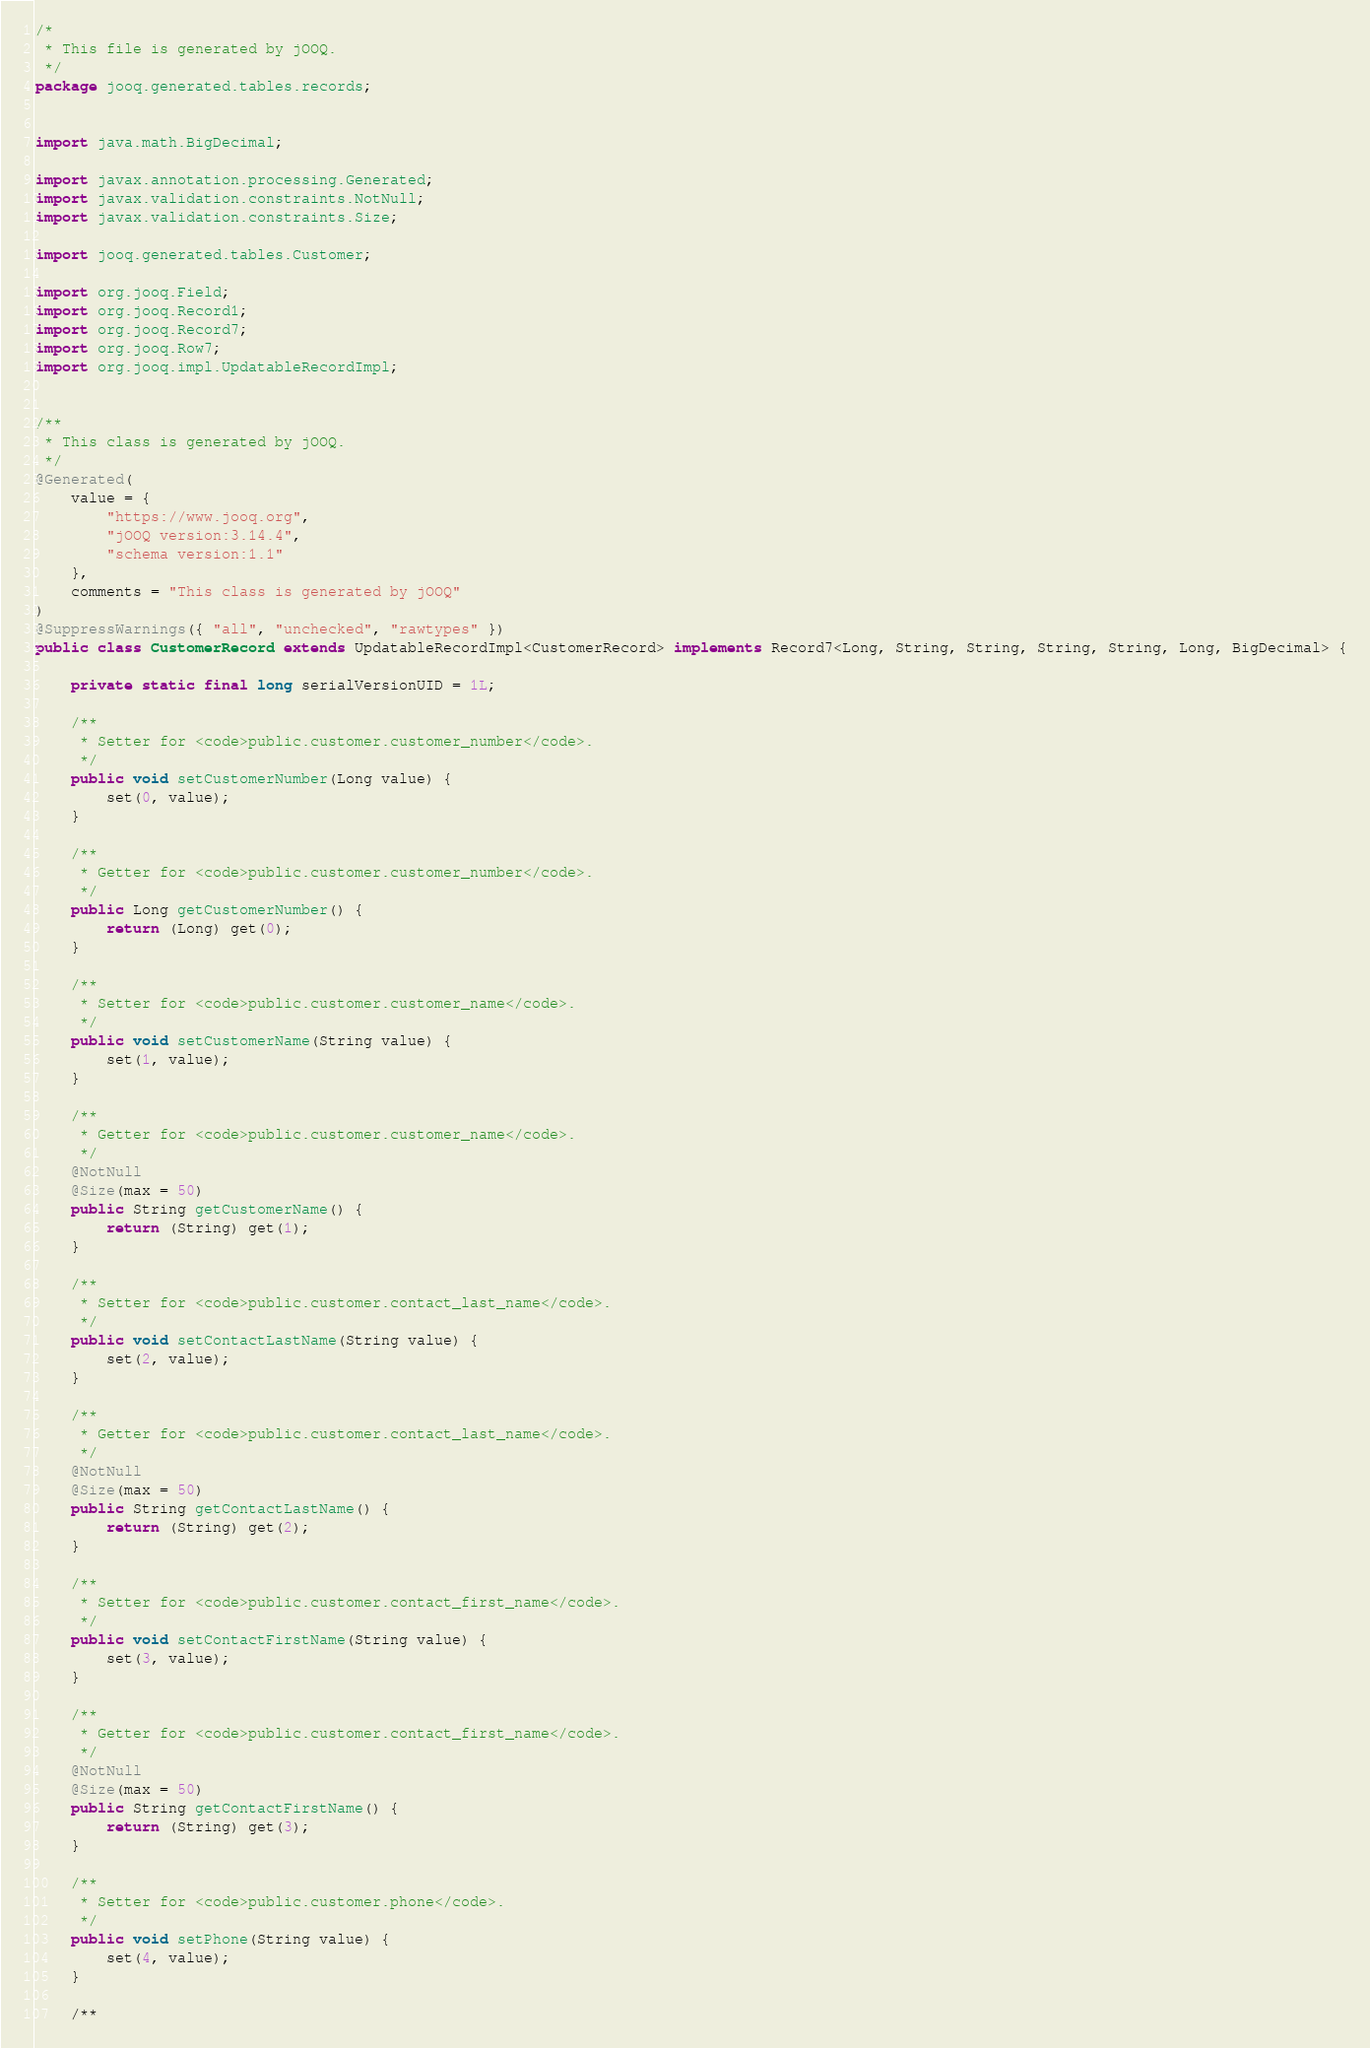Convert code to text. <code><loc_0><loc_0><loc_500><loc_500><_Java_>/*
 * This file is generated by jOOQ.
 */
package jooq.generated.tables.records;


import java.math.BigDecimal;

import javax.annotation.processing.Generated;
import javax.validation.constraints.NotNull;
import javax.validation.constraints.Size;

import jooq.generated.tables.Customer;

import org.jooq.Field;
import org.jooq.Record1;
import org.jooq.Record7;
import org.jooq.Row7;
import org.jooq.impl.UpdatableRecordImpl;


/**
 * This class is generated by jOOQ.
 */
@Generated(
    value = {
        "https://www.jooq.org",
        "jOOQ version:3.14.4",
        "schema version:1.1"
    },
    comments = "This class is generated by jOOQ"
)
@SuppressWarnings({ "all", "unchecked", "rawtypes" })
public class CustomerRecord extends UpdatableRecordImpl<CustomerRecord> implements Record7<Long, String, String, String, String, Long, BigDecimal> {

    private static final long serialVersionUID = 1L;

    /**
     * Setter for <code>public.customer.customer_number</code>.
     */
    public void setCustomerNumber(Long value) {
        set(0, value);
    }

    /**
     * Getter for <code>public.customer.customer_number</code>.
     */
    public Long getCustomerNumber() {
        return (Long) get(0);
    }

    /**
     * Setter for <code>public.customer.customer_name</code>.
     */
    public void setCustomerName(String value) {
        set(1, value);
    }

    /**
     * Getter for <code>public.customer.customer_name</code>.
     */
    @NotNull
    @Size(max = 50)
    public String getCustomerName() {
        return (String) get(1);
    }

    /**
     * Setter for <code>public.customer.contact_last_name</code>.
     */
    public void setContactLastName(String value) {
        set(2, value);
    }

    /**
     * Getter for <code>public.customer.contact_last_name</code>.
     */
    @NotNull
    @Size(max = 50)
    public String getContactLastName() {
        return (String) get(2);
    }

    /**
     * Setter for <code>public.customer.contact_first_name</code>.
     */
    public void setContactFirstName(String value) {
        set(3, value);
    }

    /**
     * Getter for <code>public.customer.contact_first_name</code>.
     */
    @NotNull
    @Size(max = 50)
    public String getContactFirstName() {
        return (String) get(3);
    }

    /**
     * Setter for <code>public.customer.phone</code>.
     */
    public void setPhone(String value) {
        set(4, value);
    }

    /**</code> 